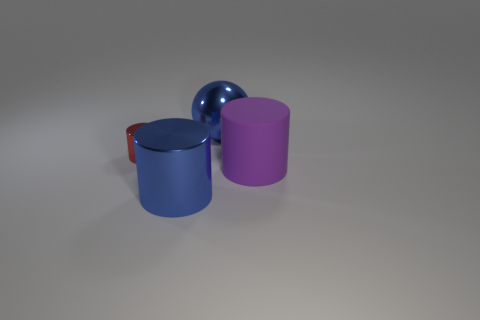Add 4 cubes. How many objects exist? 8 Subtract all balls. How many objects are left? 3 Add 1 small cylinders. How many small cylinders are left? 2 Add 3 large blue metal objects. How many large blue metal objects exist? 5 Subtract 0 red cubes. How many objects are left? 4 Subtract all small shiny cylinders. Subtract all spheres. How many objects are left? 2 